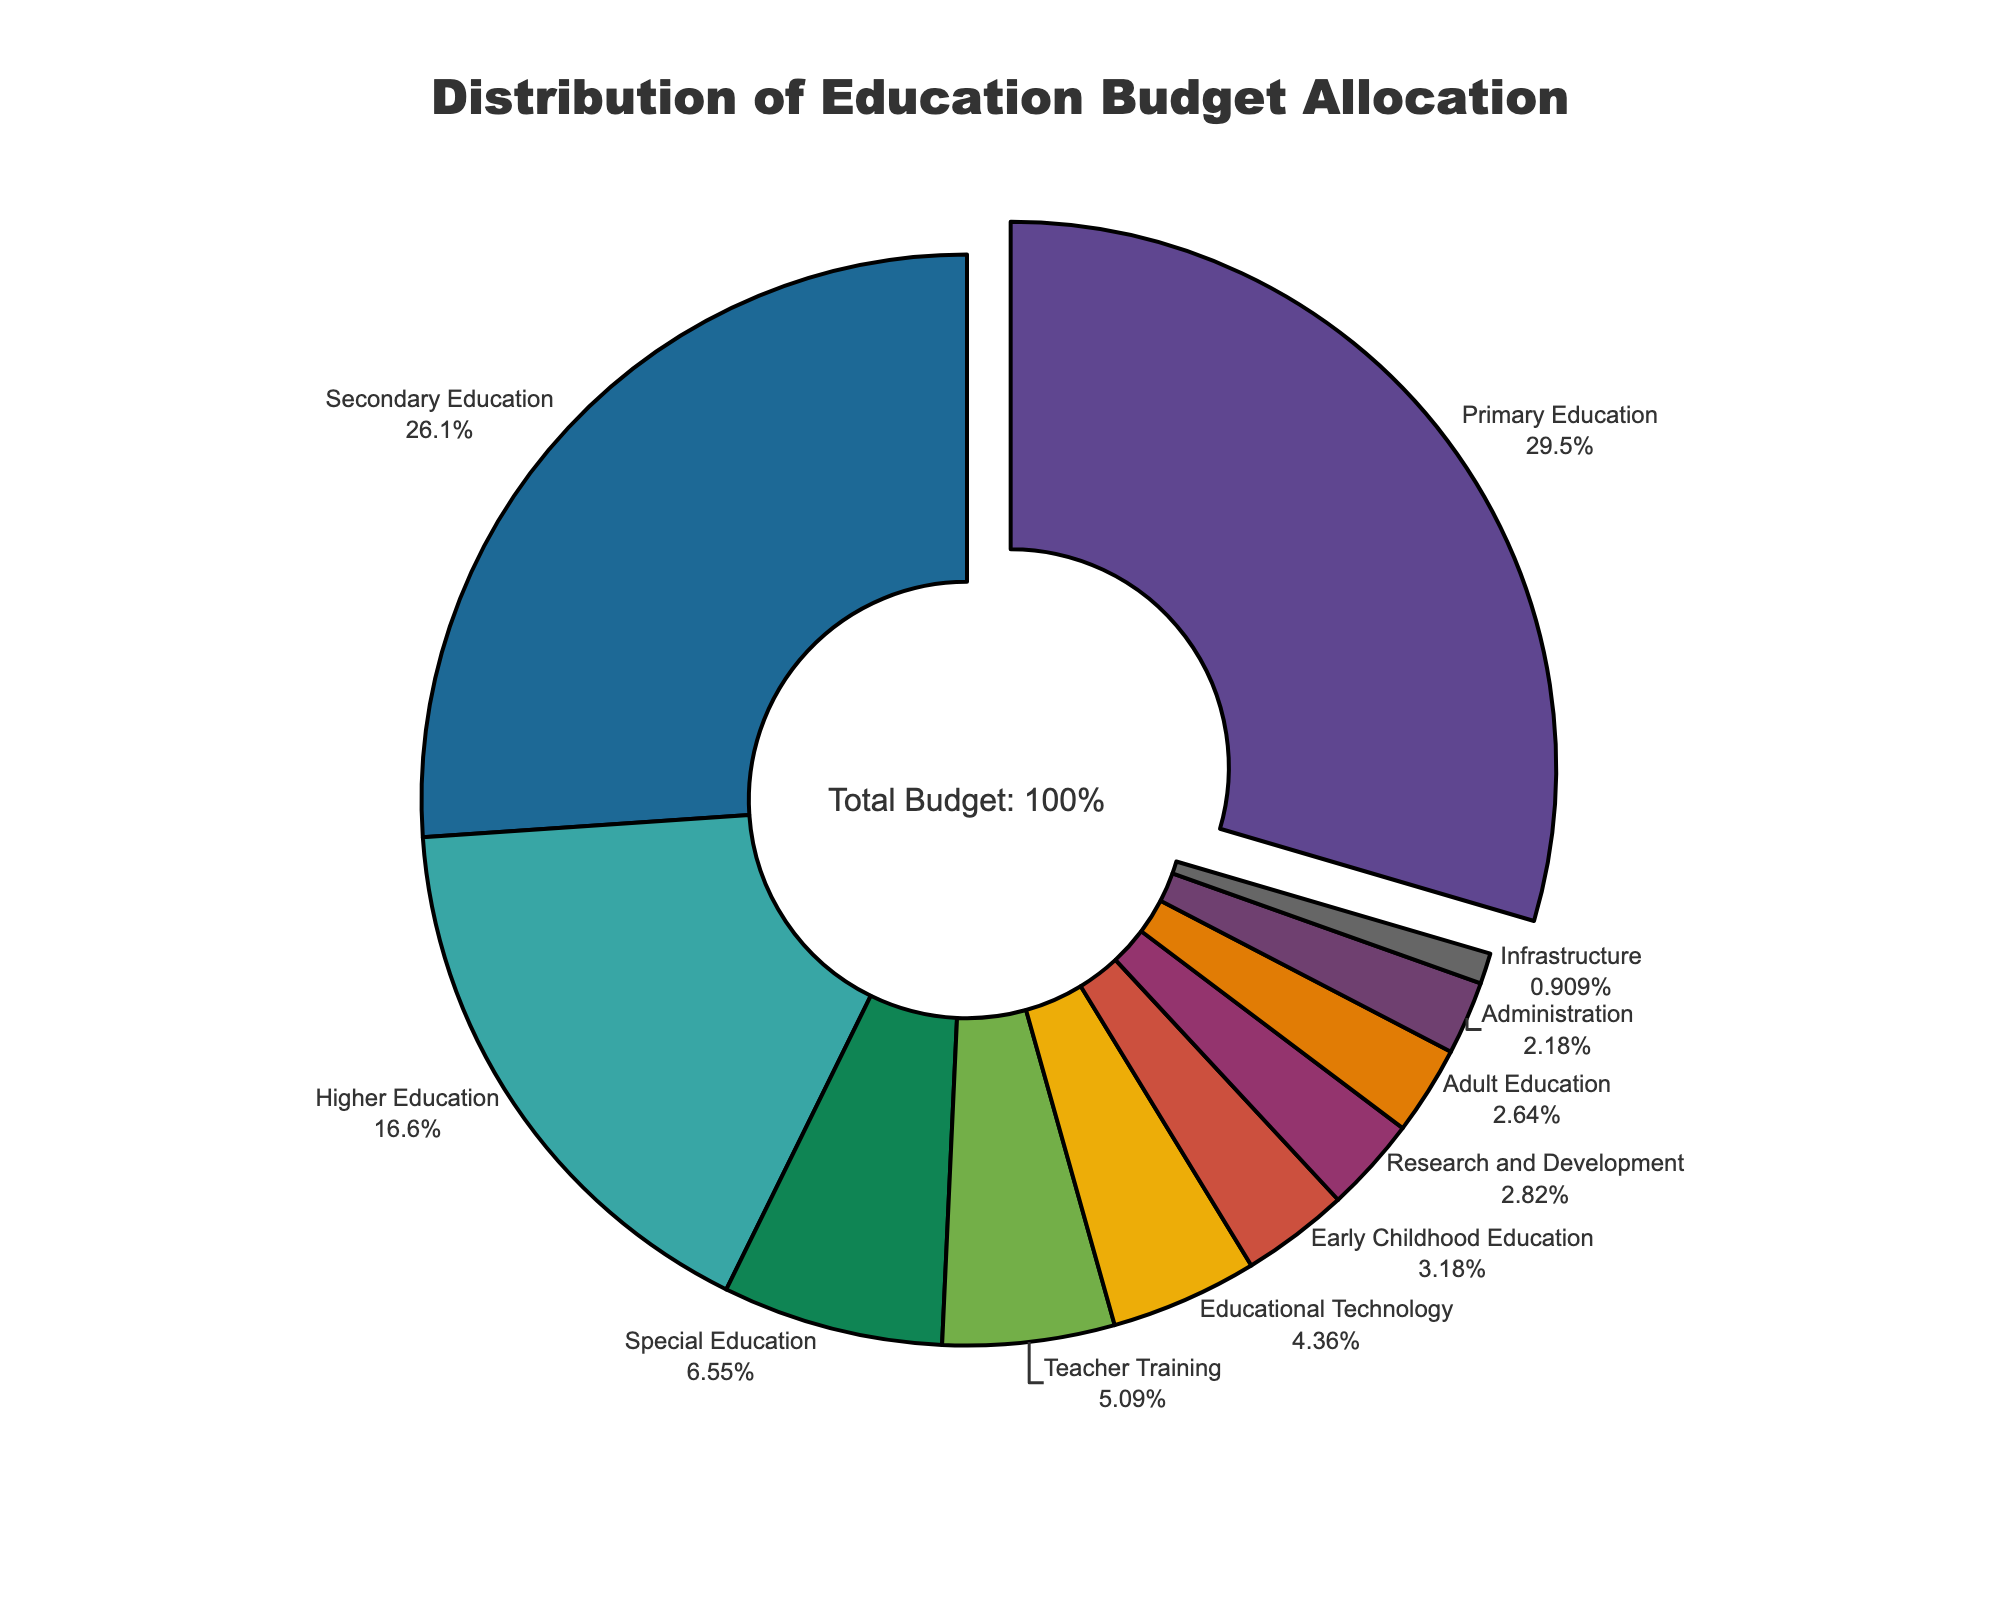Which sector has the highest budget allocation? By looking at the pie chart, we can identify the sector with the largest slice. The label and percentage displayed show that Primary Education has the largest allocation.
Answer: Primary Education Compare the budget allocation between Secondary Education and Higher Education. Locate the slices for Secondary Education and Higher Education. Secondary Education has 28.7%, while Higher Education has 18.3%, meaning Secondary Education has a higher allocation.
Answer: Secondary Education What is the total percentage allocated to Primary Education and Secondary Education combined? Add the percentages of Primary Education (32.5%) and Secondary Education (28.7%) together. 32.5 + 28.7 = 61.2%.
Answer: 61.2% Which sectors have less than 5% budget allocation? Identify the slices whose labels show percentages below 5%. Educational Technology (4.8%), Adult Education (2.9%), Early Childhood Education (3.5%), Research and Development (3.1%), and Administration (2.4%) all have less than 5%.
Answer: Educational Technology, Adult Education, Early Childhood Education, Research and Development, Administration How much more budget does Primary Education have compared to Special Education? Subtract the percentage of Special Education (7.2%) from the percentage of Primary Education (32.5%). 32.5 - 7.2 = 25.3.
Answer: 25.3% What is the average budget allocation across all sectors? Sum all the percentages allocated to each sector and divide by the number of sectors. (32.5 + 28.7 + 18.3 + 7.2 + 5.6 + 4.8 + 2.9 + 3.5 + 3.1 + 2.4 + 1.0) / 11 = 11.0%.
Answer: 11.0% Identify the sector with the smallest budget allocation. Find the slice with the smallest percentage. The figure indicates the smallest allocation is for Infrastructure at 1.0%.
Answer: Infrastructure 